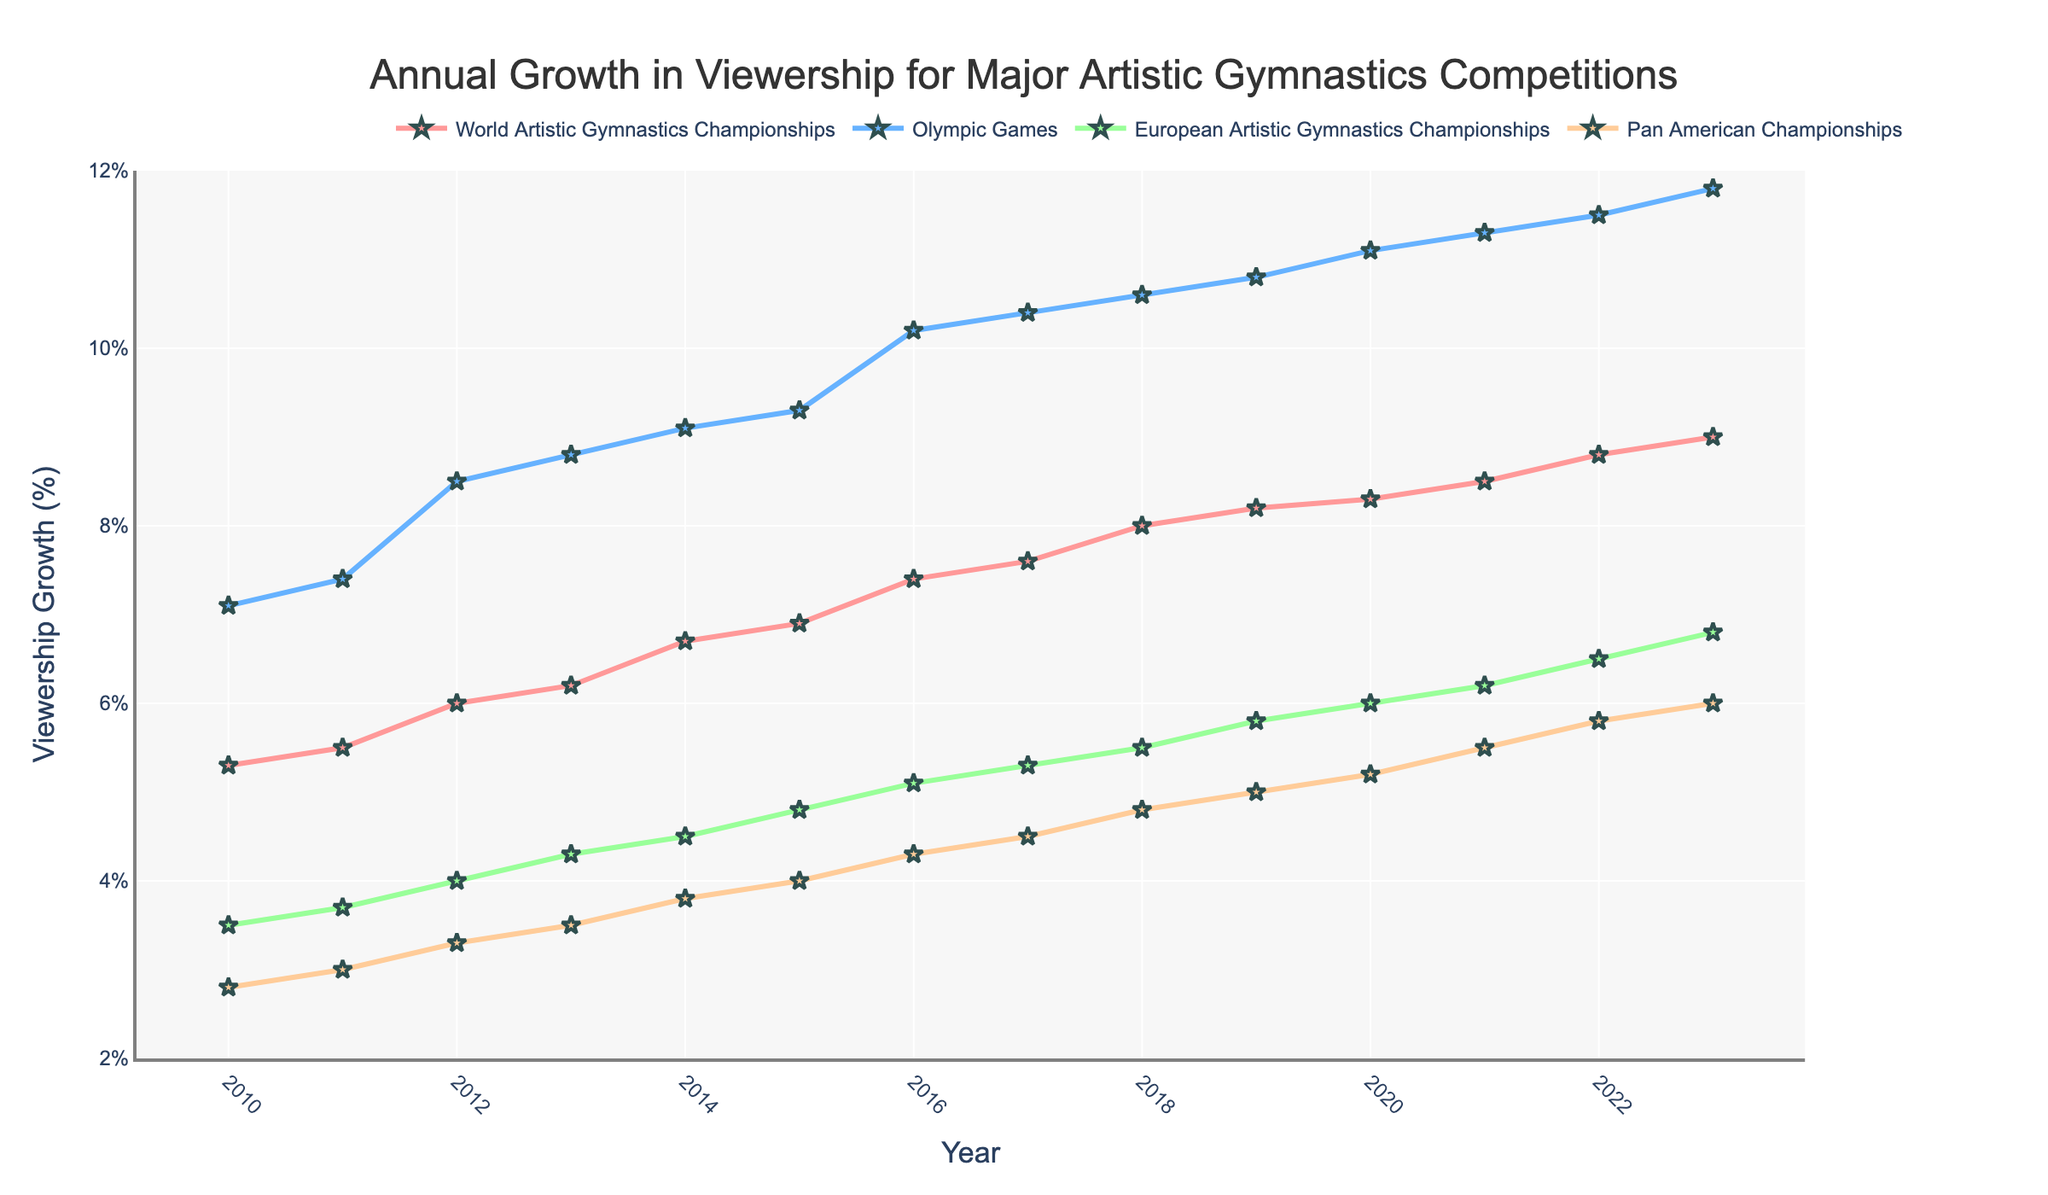What are the colors used for each competition in the plot? The colors used for the competitions are different shades: pink for the World Artistic Gymnastics Championships, blue for the Olympic Games, green for the European Artistic Gymnastics Championships, and orange for the Pan American Championships.
Answer: Pink, Blue, Green, Orange What does the y-axis represent? The y-axis represents the percentage of annual growth in viewership for major artistic gymnastics competitions.
Answer: Percentage of annual growth in viewership In what year did the Olympic Games see the highest growth in viewership, according to the plot? The plot shows that the Olympic Games had the highest growth in viewership in 2023.
Answer: 2023 By how much did the viewership growth of the Olympic Games increase from 2010 to 2016? The viewership growth for the Olympic Games in 2010 was 7.1%, and in 2016 it was 10.2%. The increase is 10.2% - 7.1% = 3.1%.
Answer: 3.1% Which competition had the smallest overall growth rate in viewership from 2010 to 2023? By comparing the end values in 2023, the Pan American Championships had the lowest growth rate, with a viewership growth of only 6.0%.
Answer: Pan American Championships Compare the viewership growth of the European Artistic Gymnastics Championships in 2017 to that of the World Artistic Gymnastics Championships in the same year. In 2017, the viewership growth of the European Artistic Gymnastics Championships was 5.3%, and the World Artistic Gymnastics Championships was 7.6%.
Answer: 5.3% for European, 7.6% for World What is the trend in viewership growth for the World Artistic Gymnastics Championships from 2010 to 2023? The trend for the World Artistic Gymnastics Championships shows a steady increase in viewership growth from 5.3% in 2010 to 9.0% in 2023.
Answer: Steady increase Which two competitions have their growth rates closest to each other in the year 2023? In 2023, the World Artistic Gymnastics Championships had a growth rate of 9.0%, and the Pan American Championships had a growth rate of 6.0%, making the closest rates between the European Artistic Gymnastics Championships (6.8%) and Pan American Championships (6.0%).
Answer: European Artistic Gymnastics Championships and Pan American Championships If we average the 2023 viewership growth of all four competitions, what would it be? Sum the 2023 growth percentages: 9.0% (World) + 11.8% (Olympic) + 6.8% (European) + 6.0% (Pan American) = 33.6%. Divide by four to find the average: 33.6% / 4 = 8.4%.
Answer: 8.4% 